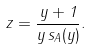<formula> <loc_0><loc_0><loc_500><loc_500>z = \frac { y + 1 } { y \, s _ { A } ( y ) } .</formula> 